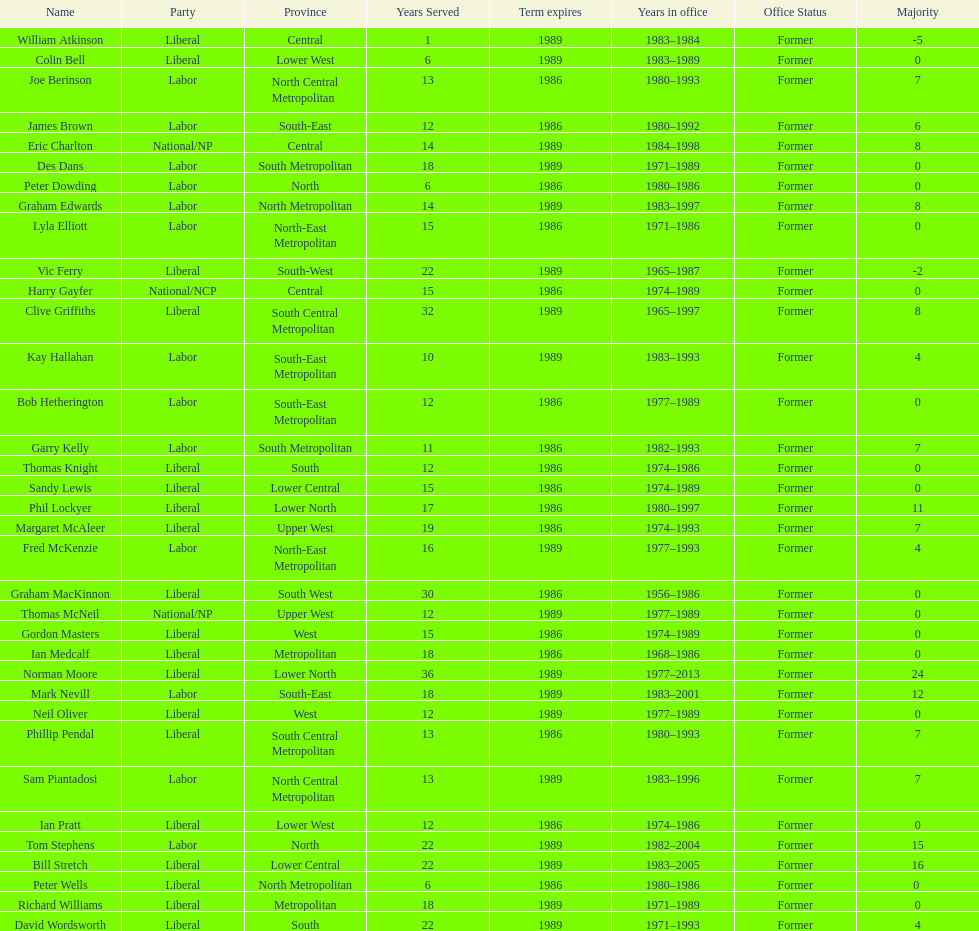How many members were party of lower west province? 2. 